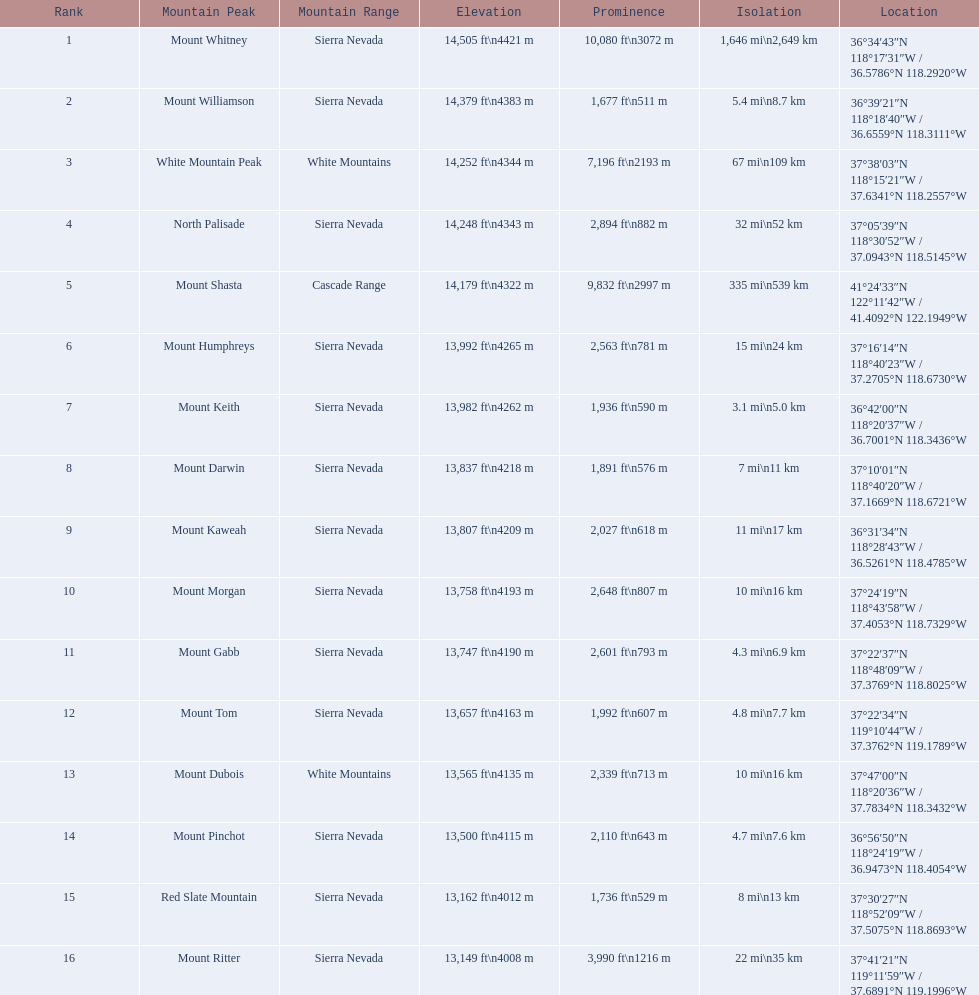Which mountain tops have the greatest elevation in california? Mount Whitney, Mount Williamson, White Mountain Peak, North Palisade, Mount Shasta, Mount Humphreys, Mount Keith, Mount Darwin, Mount Kaweah, Mount Morgan, Mount Gabb, Mount Tom, Mount Dubois, Mount Pinchot, Red Slate Mountain, Mount Ritter. Of these, which are not located in the sierra nevada range? White Mountain Peak, Mount Shasta, Mount Dubois. Of the mountains not within the sierra nevada range, which is the only one in the cascade range? Mount Shasta. 